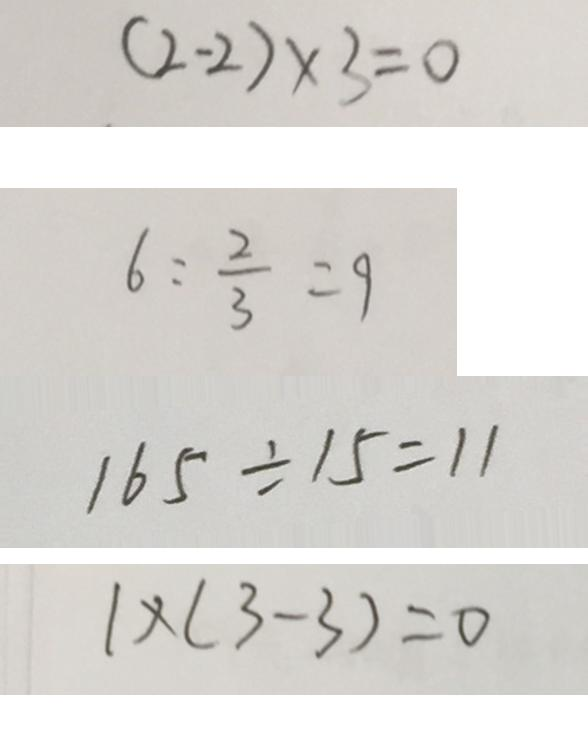Convert formula to latex. <formula><loc_0><loc_0><loc_500><loc_500>( 2 - 2 ) \times 3 = 0 
 6 : \frac { 2 } { 3 } = 9 
 1 6 5 \div 1 5 = 1 1 
 1 \times ( 3 - 3 ) = 0</formula> 